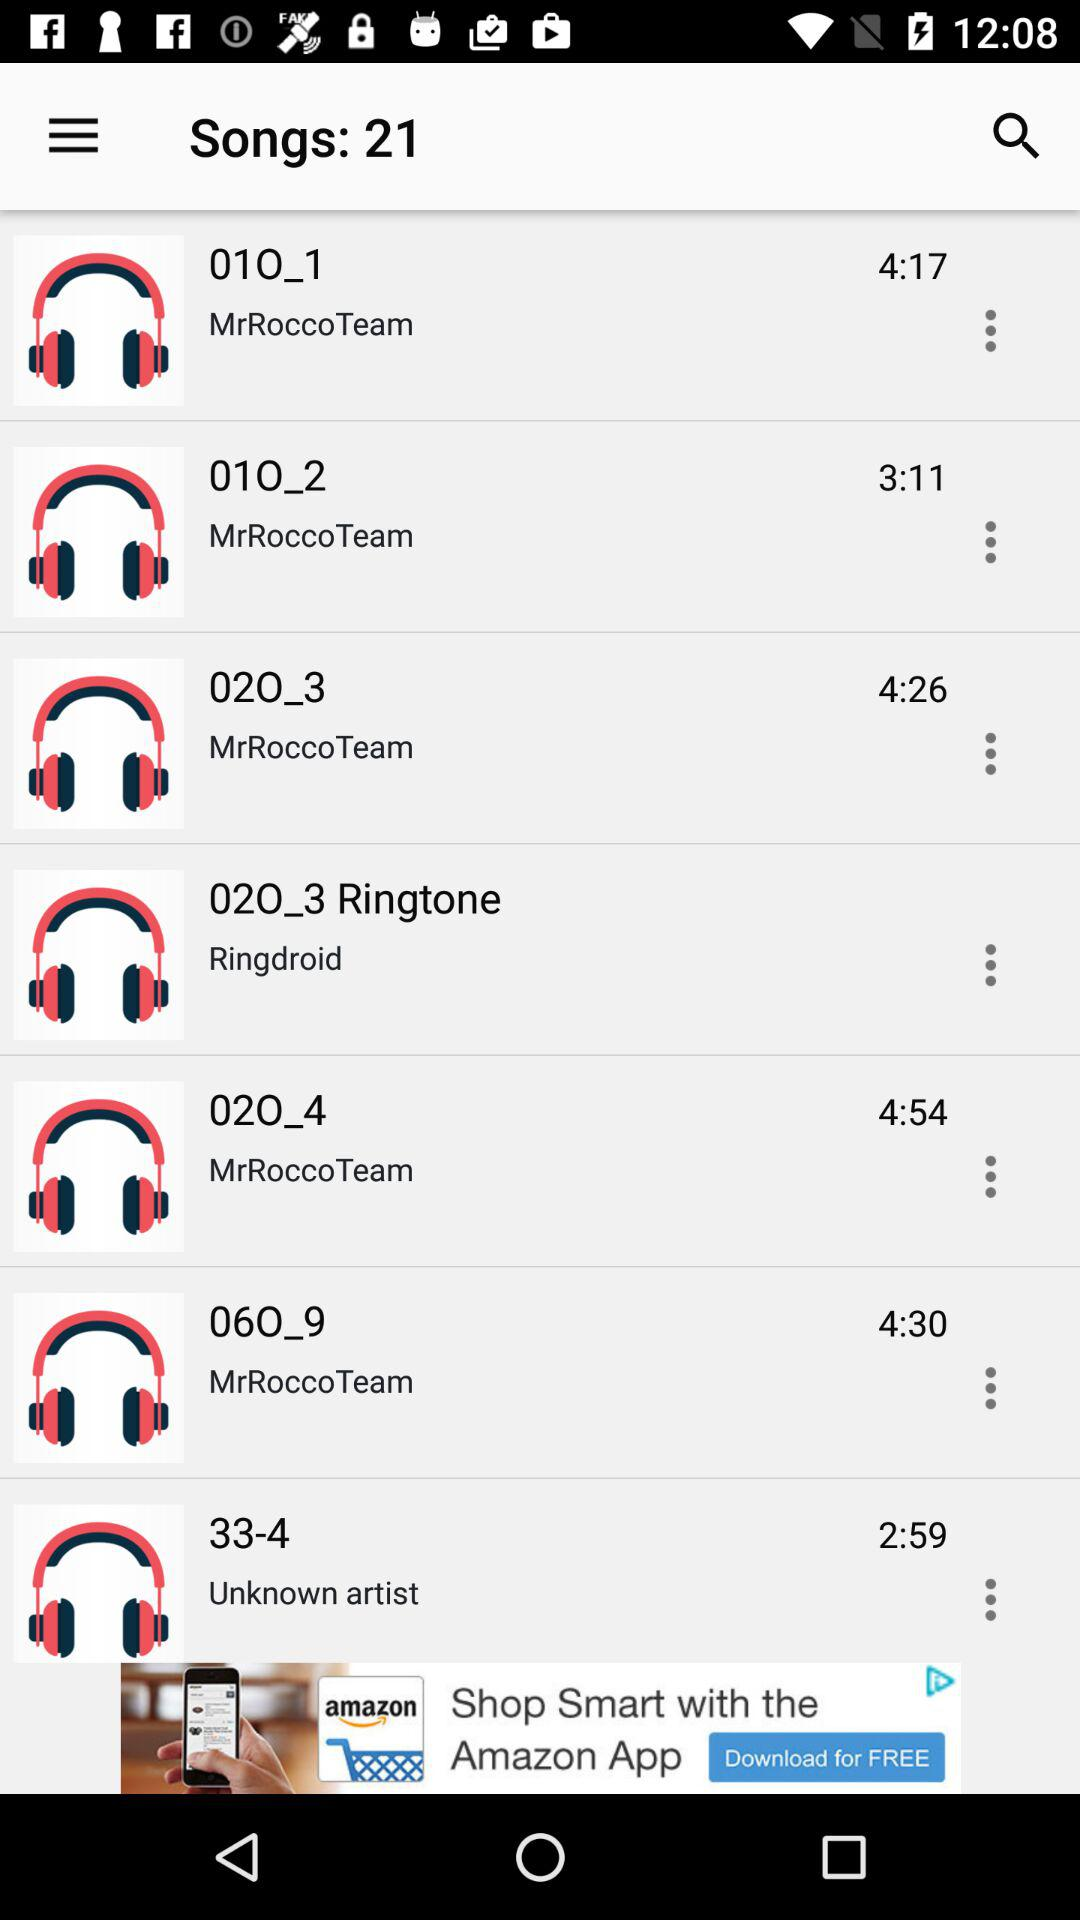What is the duration of "02O_3"? The duration of "02O_3" is 4 minutes and 26 seconds. 